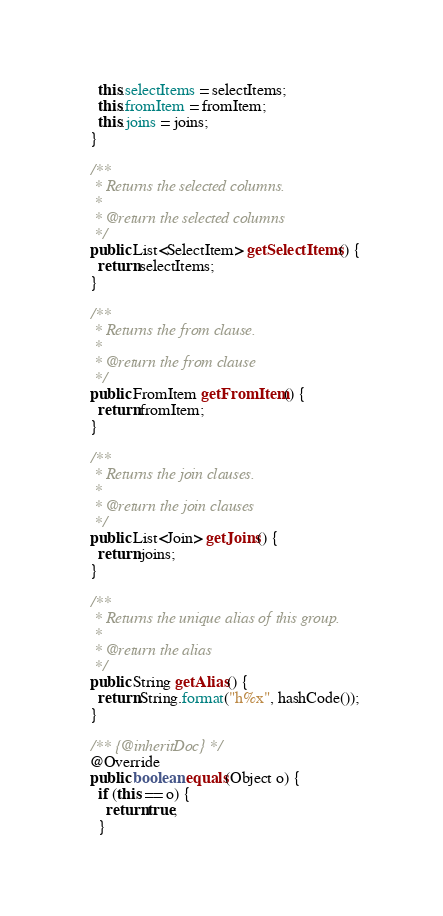Convert code to text. <code><loc_0><loc_0><loc_500><loc_500><_Java_>    this.selectItems = selectItems;
    this.fromItem = fromItem;
    this.joins = joins;
  }

  /**
   * Returns the selected columns.
   *
   * @return the selected columns
   */
  public List<SelectItem> getSelectItems() {
    return selectItems;
  }

  /**
   * Returns the from clause.
   *
   * @return the from clause
   */
  public FromItem getFromItem() {
    return fromItem;
  }

  /**
   * Returns the join clauses.
   *
   * @return the join clauses
   */
  public List<Join> getJoins() {
    return joins;
  }

  /**
   * Returns the unique alias of this group.
   *
   * @return the alias
   */
  public String getAlias() {
    return String.format("h%x", hashCode());
  }

  /** {@inheritDoc} */
  @Override
  public boolean equals(Object o) {
    if (this == o) {
      return true;
    }</code> 